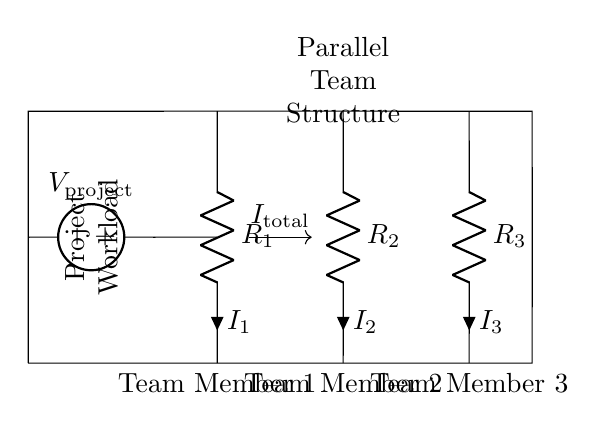What is the total current entering the circuit? The total current, denoted as I total, is the current that branches off into each of the parallel resistors in the circuit. It's indicated by the arrow labeled I total at the junction where the current splits for Team Members.
Answer: I total What are the values of the resistors labeled in the circuit? The resistors in the circuit are labeled R1, R2, and R3. Each label indicates the respective team members' contribution to the workload in terms of resistive value. However, exact numeric resistance values are not provided in the diagram itself.
Answer: R1, R2, R3 How does the workload distribute among the team members? The workload distribution follows the principles of parallel resistors. Each team member's workload corresponds to their respective resistor's resistance value; the lesser the resistance, the greater the current (or workload) through that team member.
Answer: Parallel Which team member experiences the highest current? To determine which team member experiences the highest current, we consider the resistance values labeled R1, R2, and R3. The member with the lowest resistance draws the highest current based on the current divider principle. The diagram does not provide numeric values, but it represents that relationship.
Answer: Lowest resistance What does the voltage source represent in this circuit? The voltage source, labeled as V project, represents the overall project workload that is being distributed across the team members. It sets the potential difference that drives the current through the parallel resistors.
Answer: V project If R1 is decreased, what happens to I1? If R1 is decreased, according to the current divider principle, I1 will increase because the resistive value of the path is lower and thus allows more current to flow through that branch. This reflects that higher current indicates a greater share of the workload for that team member.
Answer: Increases 